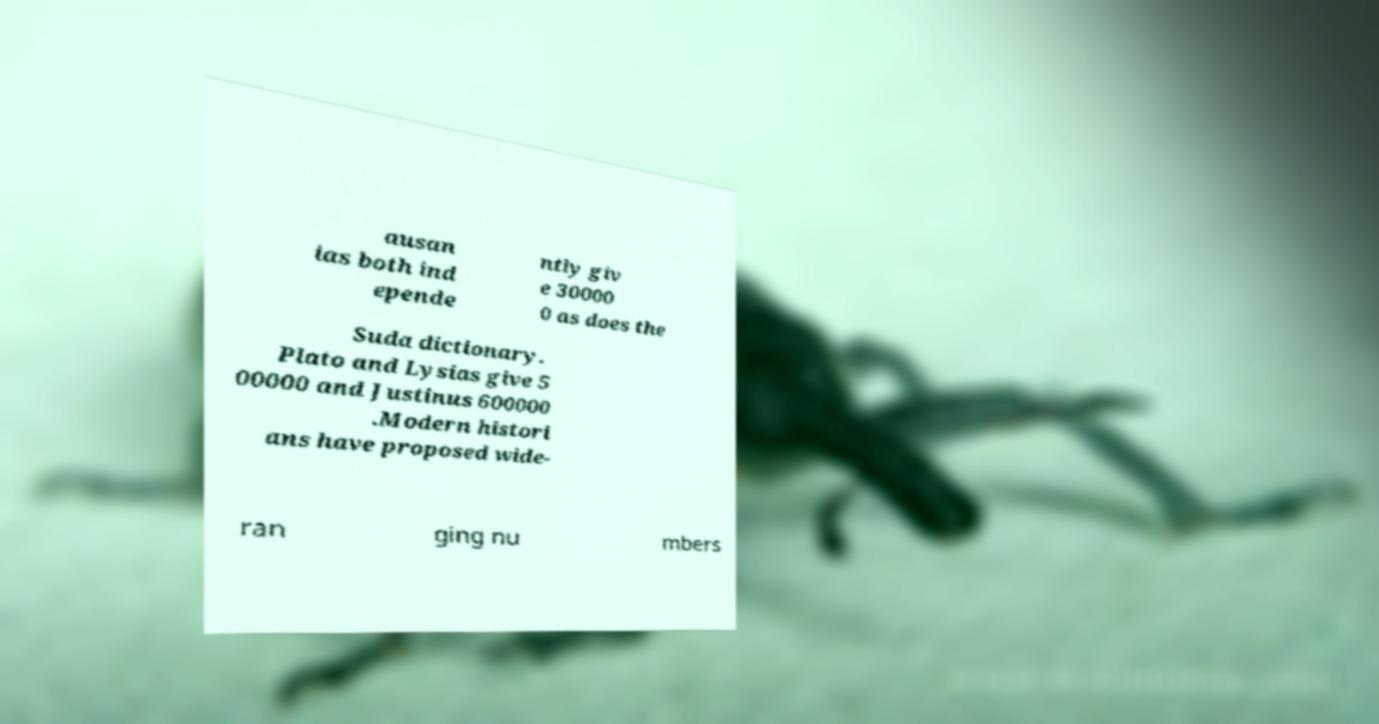There's text embedded in this image that I need extracted. Can you transcribe it verbatim? ausan ias both ind epende ntly giv e 30000 0 as does the Suda dictionary. Plato and Lysias give 5 00000 and Justinus 600000 .Modern histori ans have proposed wide- ran ging nu mbers 